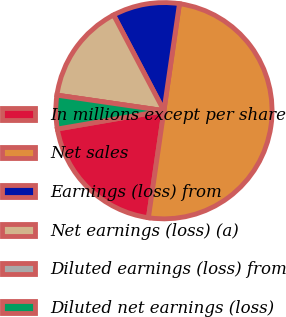<chart> <loc_0><loc_0><loc_500><loc_500><pie_chart><fcel>In millions except per share<fcel>Net sales<fcel>Earnings (loss) from<fcel>Net earnings (loss) (a)<fcel>Diluted earnings (loss) from<fcel>Diluted net earnings (loss)<nl><fcel>20.0%<fcel>49.99%<fcel>10.0%<fcel>15.0%<fcel>0.0%<fcel>5.0%<nl></chart> 